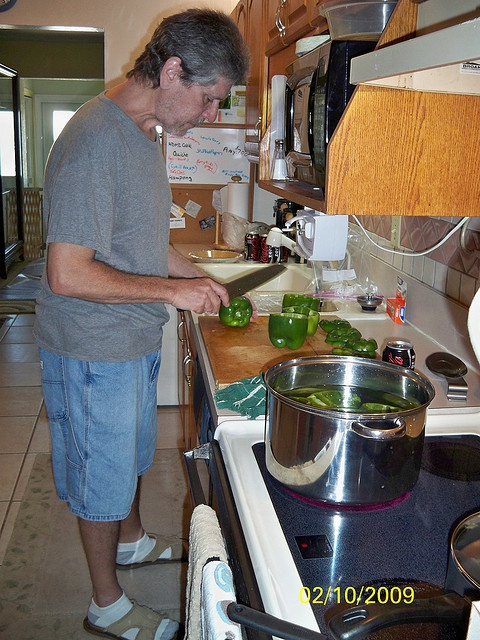Describe the objects in this image and their specific colors. I can see people in gray tones, oven in gray, black, and lightgray tones, microwave in gray, black, and maroon tones, sink in gray, tan, darkgray, and lightgray tones, and cup in gray, darkgray, and lightgray tones in this image. 